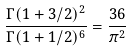<formula> <loc_0><loc_0><loc_500><loc_500>\frac { \Gamma ( 1 + 3 / 2 ) ^ { 2 } } { \Gamma ( 1 + 1 / 2 ) ^ { 6 } } = \frac { 3 6 } { \pi ^ { 2 } }</formula> 